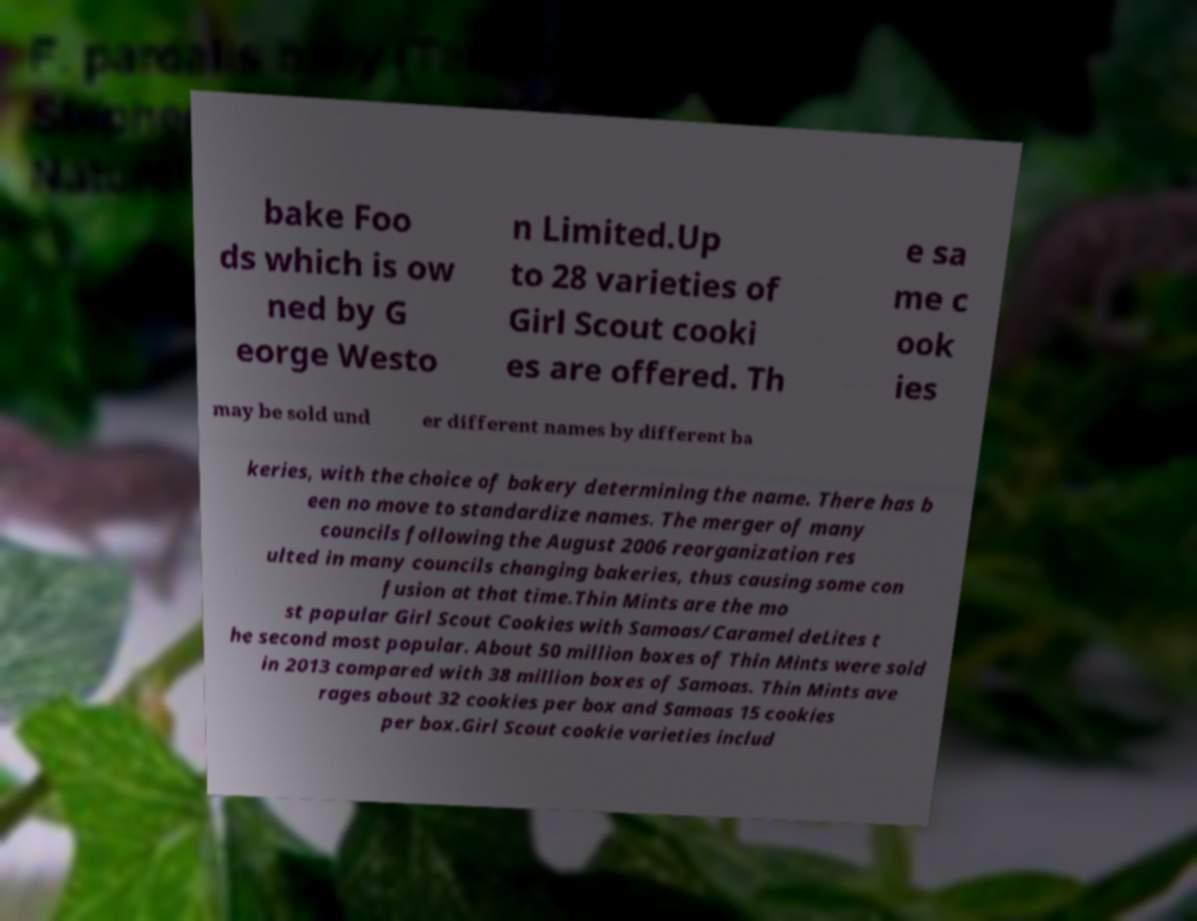Could you extract and type out the text from this image? bake Foo ds which is ow ned by G eorge Westo n Limited.Up to 28 varieties of Girl Scout cooki es are offered. Th e sa me c ook ies may be sold und er different names by different ba keries, with the choice of bakery determining the name. There has b een no move to standardize names. The merger of many councils following the August 2006 reorganization res ulted in many councils changing bakeries, thus causing some con fusion at that time.Thin Mints are the mo st popular Girl Scout Cookies with Samoas/Caramel deLites t he second most popular. About 50 million boxes of Thin Mints were sold in 2013 compared with 38 million boxes of Samoas. Thin Mints ave rages about 32 cookies per box and Samoas 15 cookies per box.Girl Scout cookie varieties includ 